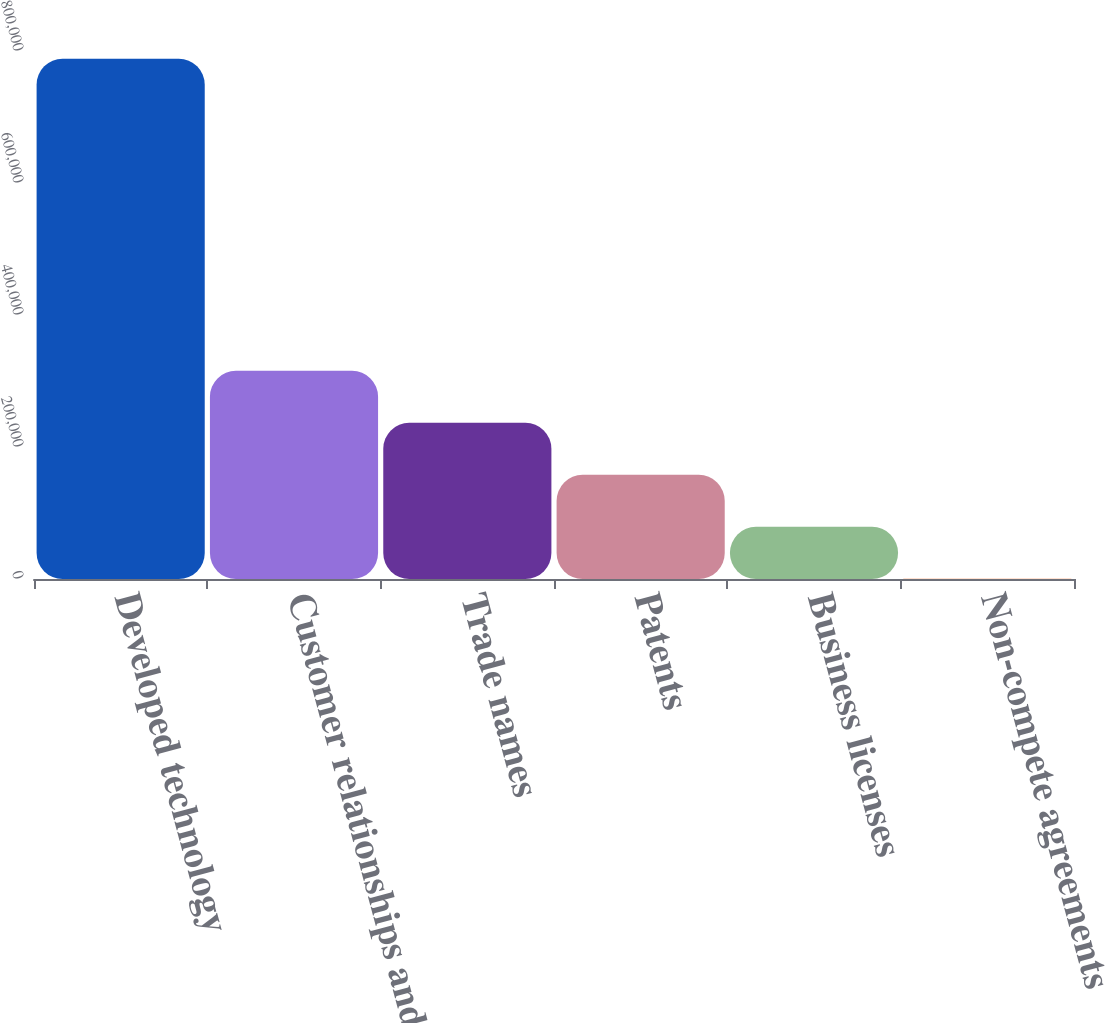Convert chart. <chart><loc_0><loc_0><loc_500><loc_500><bar_chart><fcel>Developed technology<fcel>Customer relationships and<fcel>Trade names<fcel>Patents<fcel>Business licenses<fcel>Non-compete agreements<nl><fcel>788274<fcel>315443<fcel>236638<fcel>157833<fcel>79028.1<fcel>223<nl></chart> 